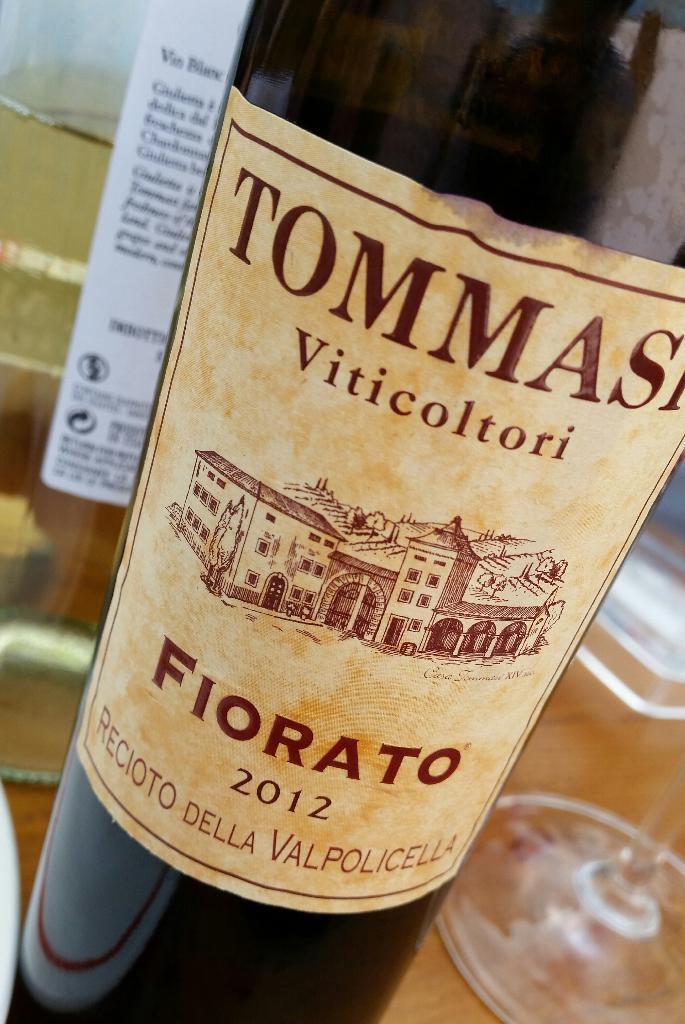<image>
Summarize the visual content of the image. A bottle of Tommasi Viticoltori that was made in 2012 